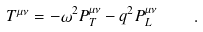Convert formula to latex. <formula><loc_0><loc_0><loc_500><loc_500>T ^ { \mu \nu } = - \omega ^ { 2 } P _ { T } ^ { \mu \nu } - q ^ { 2 } P _ { L } ^ { \mu \nu } \quad .</formula> 